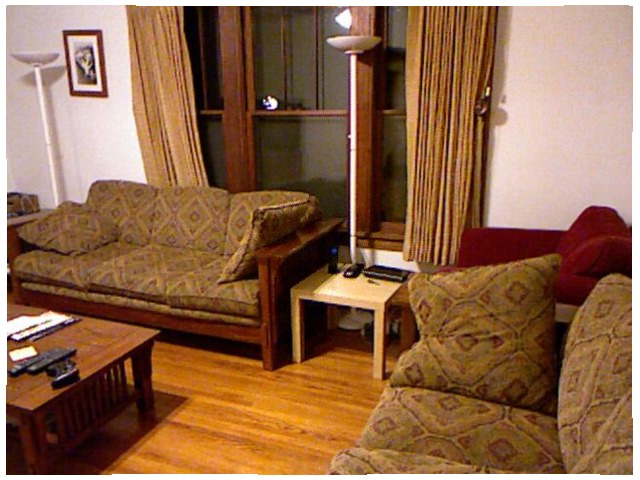<image>
Is there a table in front of the lamp? Yes. The table is positioned in front of the lamp, appearing closer to the camera viewpoint. Is the sofa in front of the table? No. The sofa is not in front of the table. The spatial positioning shows a different relationship between these objects. Is there a lamp under the pillow? No. The lamp is not positioned under the pillow. The vertical relationship between these objects is different. Is there a lamp behind the table? Yes. From this viewpoint, the lamp is positioned behind the table, with the table partially or fully occluding the lamp. Is the lamp behind the table? No. The lamp is not behind the table. From this viewpoint, the lamp appears to be positioned elsewhere in the scene. 